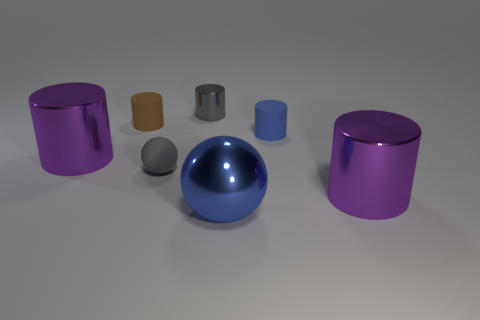How many purple cylinders must be subtracted to get 1 purple cylinders? 1 Subtract all rubber cylinders. How many cylinders are left? 3 Subtract 3 cylinders. How many cylinders are left? 2 Subtract all red spheres. Subtract all purple cylinders. How many spheres are left? 2 Subtract all blue cylinders. How many yellow balls are left? 0 Subtract all blue matte cubes. Subtract all big cylinders. How many objects are left? 5 Add 2 small gray spheres. How many small gray spheres are left? 3 Add 3 large blue shiny spheres. How many large blue shiny spheres exist? 4 Add 3 tiny gray shiny cylinders. How many objects exist? 10 Subtract all gray cylinders. How many cylinders are left? 4 